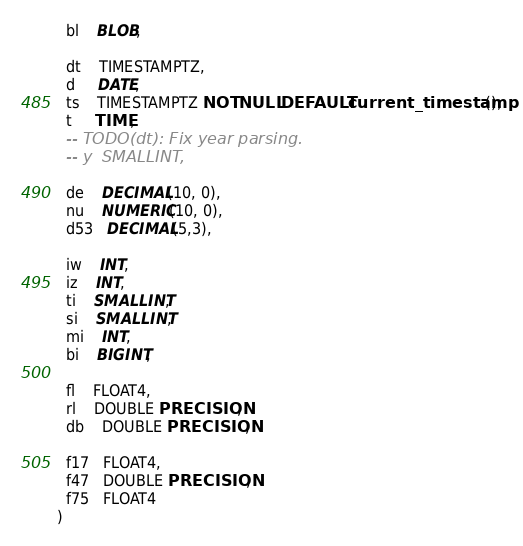<code> <loc_0><loc_0><loc_500><loc_500><_SQL_>  bl    BLOB,

  dt    TIMESTAMPTZ,
  d     DATE,
  ts    TIMESTAMPTZ NOT NULL DEFAULT current_timestamp(),
  t     TIME,
  -- TODO(dt): Fix year parsing.
  -- y  SMALLINT,

  de    DECIMAL(10, 0),
  nu    NUMERIC(10, 0),
  d53   DECIMAL(5,3),

  iw    INT,
  iz    INT,
  ti    SMALLINT,
  si    SMALLINT,
  mi    INT,
  bi    BIGINT,

  fl    FLOAT4,
  rl    DOUBLE PRECISION,
  db    DOUBLE PRECISION,

  f17   FLOAT4,
  f47   DOUBLE PRECISION,
  f75   FLOAT4
)
</code> 